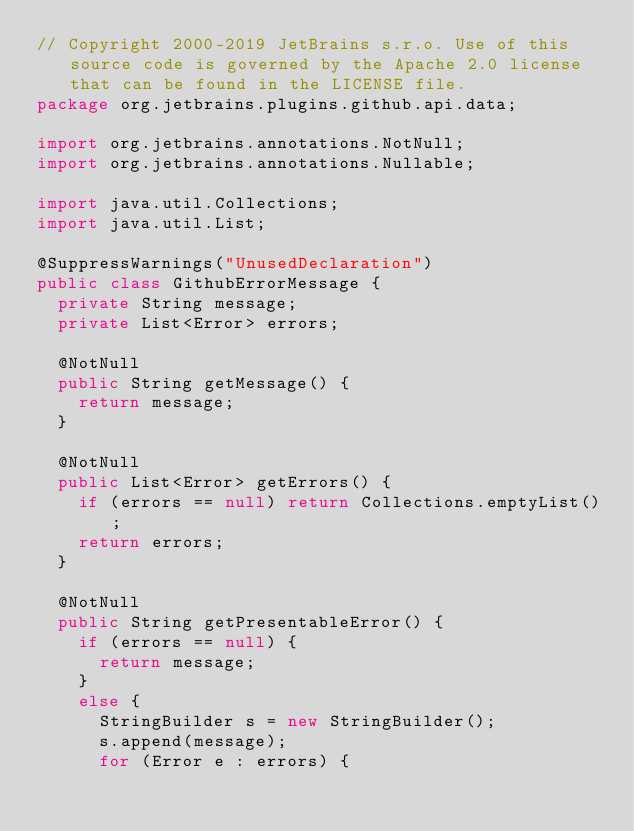Convert code to text. <code><loc_0><loc_0><loc_500><loc_500><_Java_>// Copyright 2000-2019 JetBrains s.r.o. Use of this source code is governed by the Apache 2.0 license that can be found in the LICENSE file.
package org.jetbrains.plugins.github.api.data;

import org.jetbrains.annotations.NotNull;
import org.jetbrains.annotations.Nullable;

import java.util.Collections;
import java.util.List;

@SuppressWarnings("UnusedDeclaration")
public class GithubErrorMessage {
  private String message;
  private List<Error> errors;

  @NotNull
  public String getMessage() {
    return message;
  }

  @NotNull
  public List<Error> getErrors() {
    if (errors == null) return Collections.emptyList();
    return errors;
  }

  @NotNull
  public String getPresentableError() {
    if (errors == null) {
      return message;
    }
    else {
      StringBuilder s = new StringBuilder();
      s.append(message);
      for (Error e : errors) {</code> 